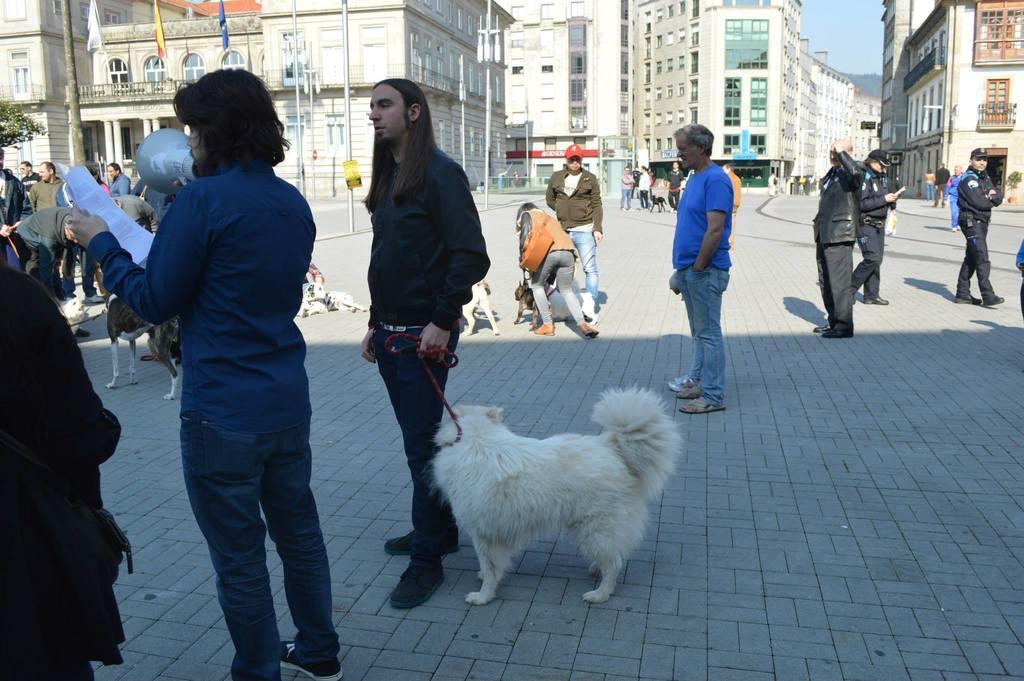Please provide a concise description of this image. In this image we can see some people, animals, paper and other objects. In the background of the image there are some buildings, poles, flags, people, trees, the sky and other objects. At the bottom of the image there is the floor. 